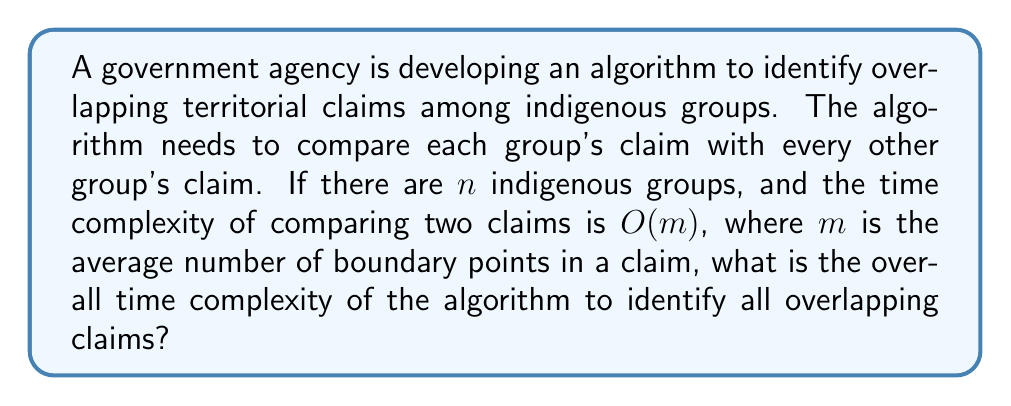Teach me how to tackle this problem. To solve this problem, we need to consider the following steps:

1) First, we need to determine how many comparisons need to be made. With $n$ indigenous groups, we need to compare each group's claim with every other group's claim. This is a combination problem where we choose 2 groups out of $n$ groups. The number of comparisons is given by the combination formula:

   $$\binom{n}{2} = \frac{n!}{2!(n-2)!} = \frac{n(n-1)}{2}$$

2) Each comparison takes $O(m)$ time, where $m$ is the average number of boundary points in a claim.

3) Therefore, the total time complexity is the product of the number of comparisons and the time for each comparison:

   $$O(\frac{n(n-1)}{2} \cdot m)$$

4) Simplifying this expression:

   $$O(\frac{n^2m - nm}{2})$$

5) In Big O notation, we drop lower order terms and constants. $n^2m$ dominates $nm$ for large $n$, so we can drop the $nm$ term. The constant factor of $\frac{1}{2}$ is also dropped in Big O notation.

6) This leaves us with the final time complexity of $O(n^2m)$.

This quadratic time complexity in terms of the number of groups ($n^2$) indicates that the algorithm may become slow for a large number of indigenous groups, which is an important consideration for a lawmaker working on legislation to protect indigenous rights.
Answer: $O(n^2m)$ 